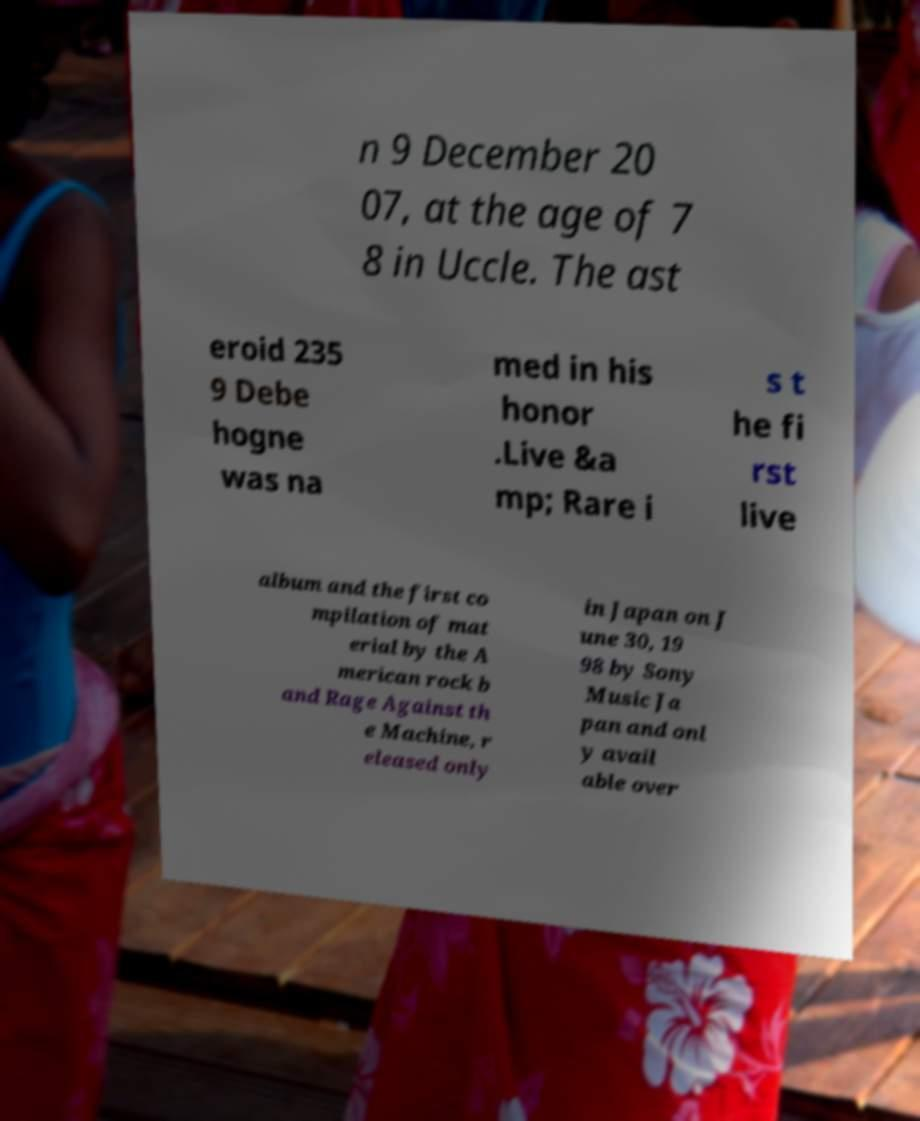There's text embedded in this image that I need extracted. Can you transcribe it verbatim? n 9 December 20 07, at the age of 7 8 in Uccle. The ast eroid 235 9 Debe hogne was na med in his honor .Live &a mp; Rare i s t he fi rst live album and the first co mpilation of mat erial by the A merican rock b and Rage Against th e Machine, r eleased only in Japan on J une 30, 19 98 by Sony Music Ja pan and onl y avail able over 